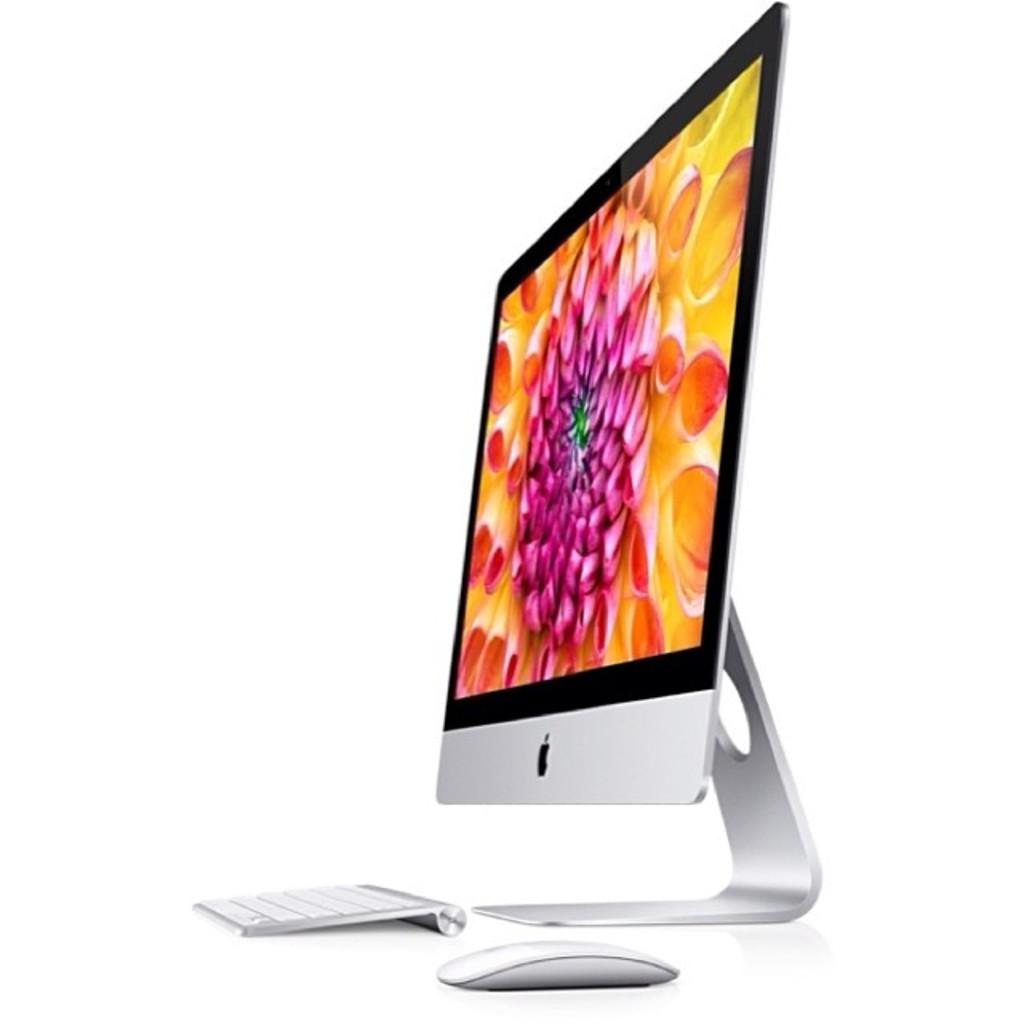What type of device is visible in the image? There is a monitor in the image. What is used for input in the image? There is a keyboard and a mouse (likely a computer mouse) in the image. How does the rain affect the monitor in the image? There is no rain present in the image, so it cannot affect the monitor. 